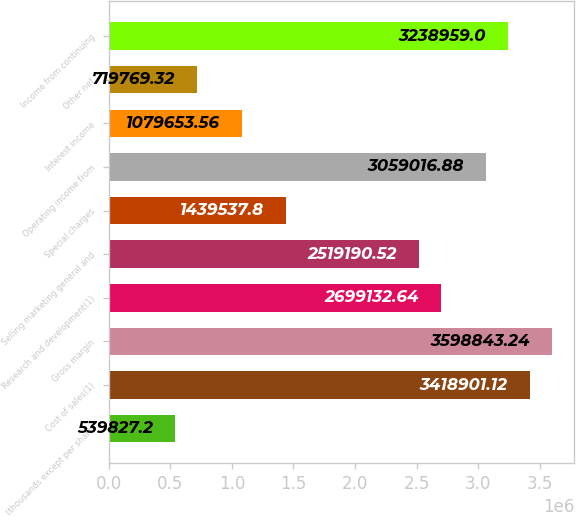<chart> <loc_0><loc_0><loc_500><loc_500><bar_chart><fcel>(thousands except per share<fcel>Cost of sales(1)<fcel>Gross margin<fcel>Research and development(1)<fcel>Selling marketing general and<fcel>Special charges<fcel>Operating income from<fcel>Interest income<fcel>Other net<fcel>Income from continuing<nl><fcel>539827<fcel>3.4189e+06<fcel>3.59884e+06<fcel>2.69913e+06<fcel>2.51919e+06<fcel>1.43954e+06<fcel>3.05902e+06<fcel>1.07965e+06<fcel>719769<fcel>3.23896e+06<nl></chart> 